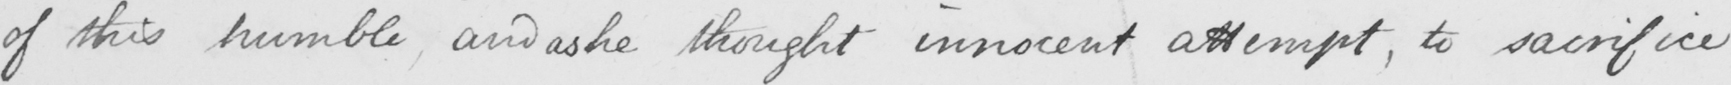Please transcribe the handwritten text in this image. of this humble , and as he thought innocent attempt , to sacrifice 